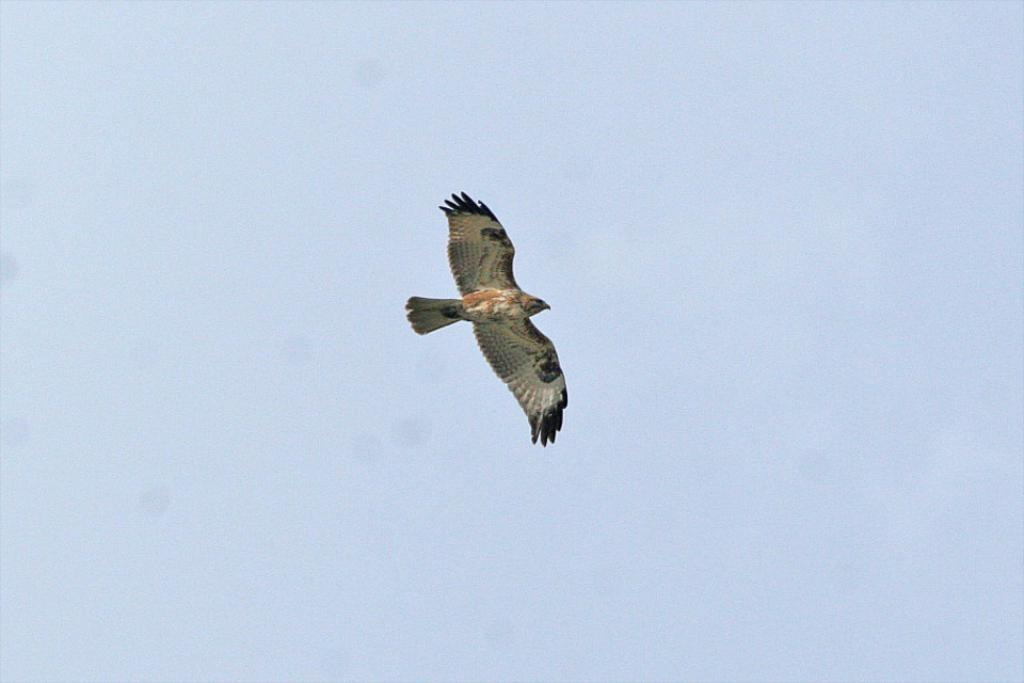What animal is the main subject of the picture? There is an eagle in the picture. What is the eagle doing in the image? The eagle is flying. What can be seen in the background of the image? The sky is visible in the background of the image. How does the eagle use steam to fly in the image? There is no steam present in the image, and eagles do not use steam to fly. The eagle is flying using its wings, not steam. 